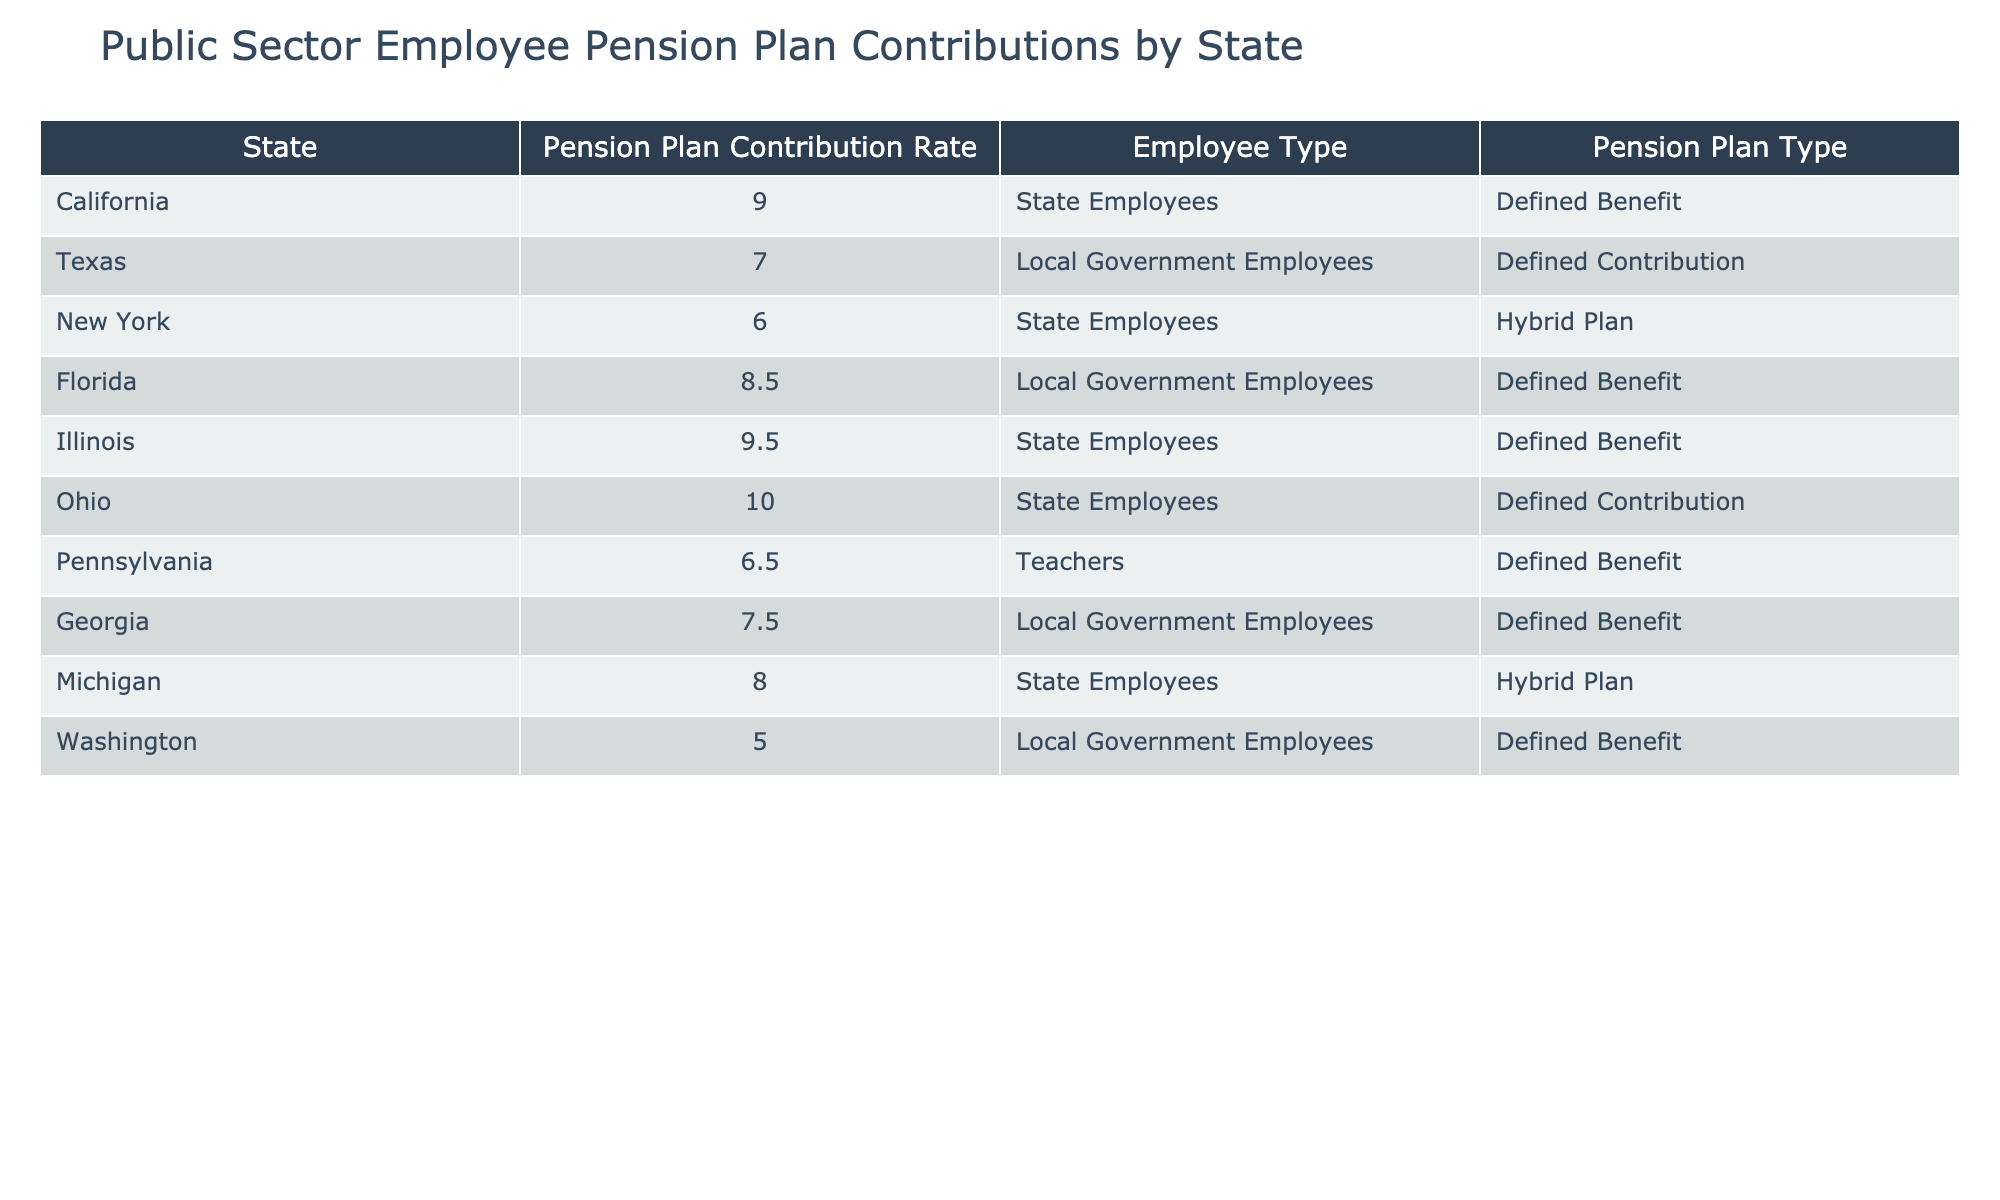What is the highest pension plan contribution rate among state employees? The table shows the contribution rates for state employees. By reviewing the entries for state employees, we find Illinois with a rate of 9.5%, which is the highest among that group.
Answer: 9.5% Which state has the lowest pension plan contribution rate for local government employees? For local government employees, we look at the relevant rows and find Washington with a contribution rate of 5.0%, which is the lowest when compared to Texas and Florida.
Answer: 5.0% What is the average pension plan contribution rate for teachers? The table has only one entry for teachers, which is Pennsylvania at 6.5%. Since there's only one value, the average is simply that single value itself.
Answer: 6.5% Is the pension plan for Oklahoma employees classified as a defined benefit? There is no entry for Oklahoma in the table, which means we cannot determine the classification of its pension plan for employees. Therefore, the answer to the question is no, we don't know.
Answer: No How many states have a pension plan contribution rate above 8% for state employees? The states with contributions above 8% for state employees are California (9.0%) and Illinois (9.5%). Counting these entries gives us a total of 2 states.
Answer: 2 What contribution rate do local government employees in Texas pay, and how does it compare to those in Florida? Texas local government employees contribute 7.0%, while Florida's contribute 8.5%. Comparing these values indicates that Florida has a higher contribution rate than Texas.
Answer: 8.5% (Florida is higher) Does any state have a pension plan contribution rate of exactly 6%? By scanning the table for a contribution rate of 6%, we find none listed matches that exact percentage. Therefore, the answer is no.
Answer: No How many different types of pension plans are listed in the table, and which one has the highest contribution rate? The table lists three types of pension plans: Defined Benefit, Defined Contribution, and Hybrid Plan. The highest contribution rate is from the Defined Benefit plan in Illinois at 9.5%.
Answer: 3 types; Defined Benefit has the highest at 9.5% 